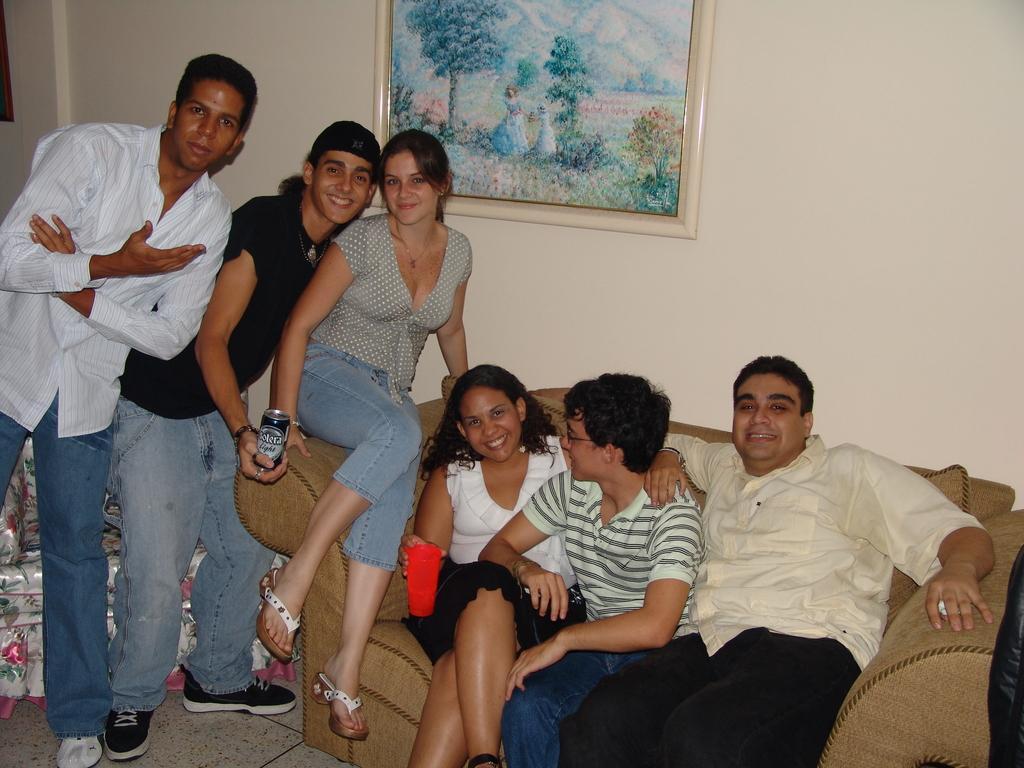Could you give a brief overview of what you see in this image? In this picture I can see four persons sitting on the couch, there are two persons standing, there are few objects, and in the background there is a frame attached to the wall. 